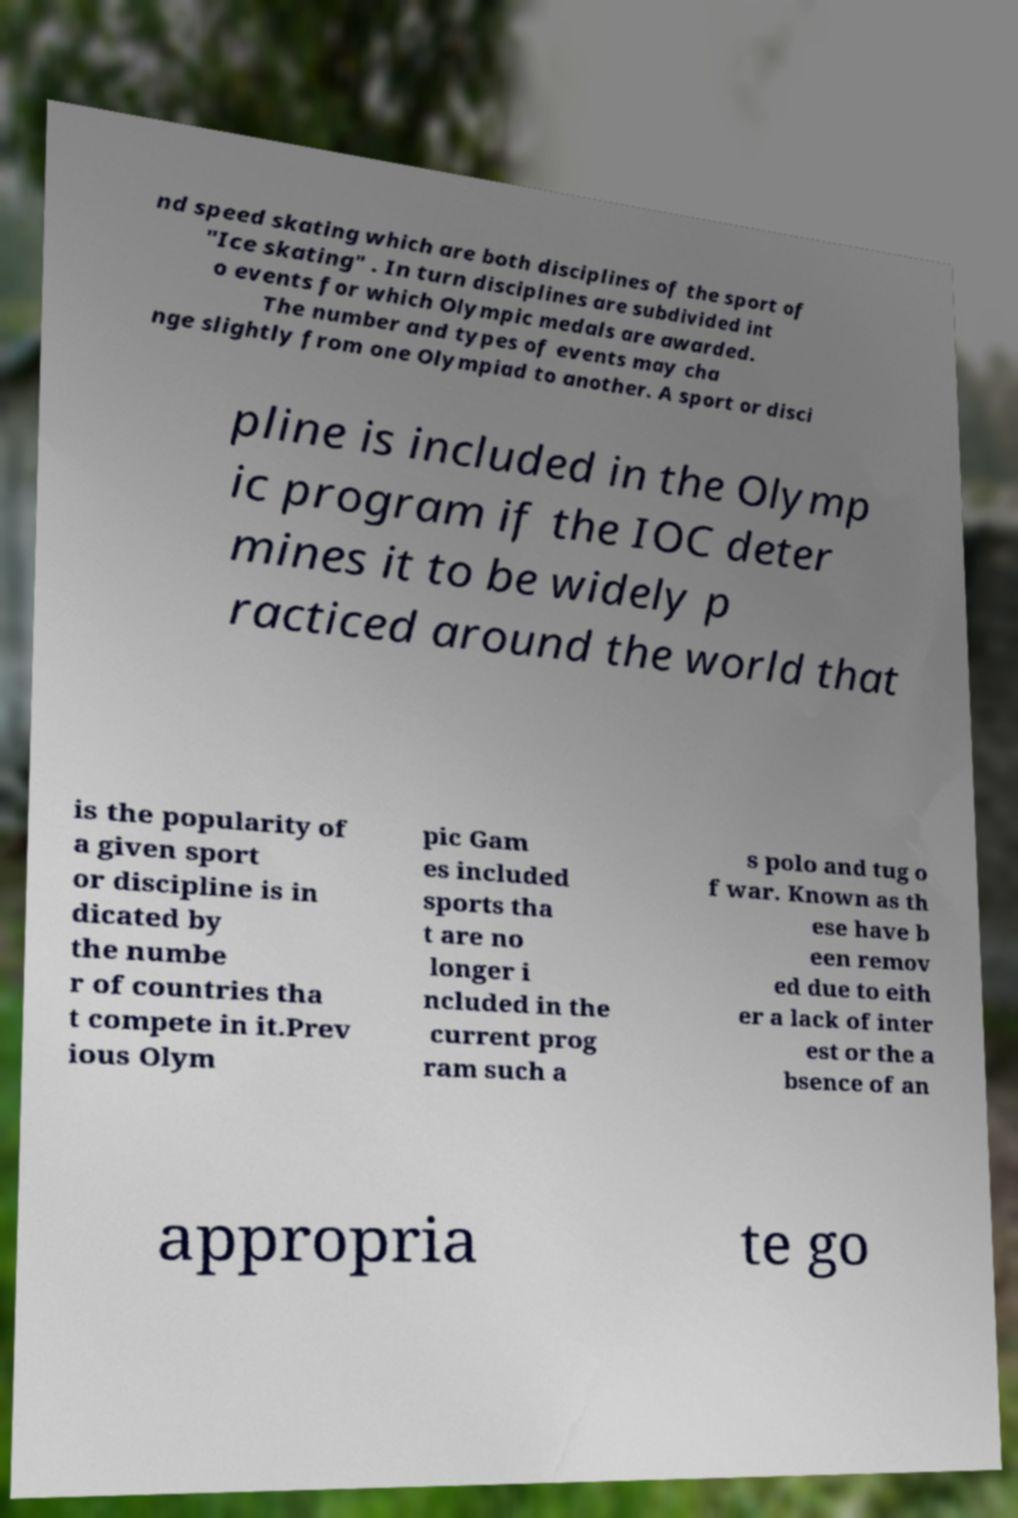Could you assist in decoding the text presented in this image and type it out clearly? nd speed skating which are both disciplines of the sport of "Ice skating" . In turn disciplines are subdivided int o events for which Olympic medals are awarded. The number and types of events may cha nge slightly from one Olympiad to another. A sport or disci pline is included in the Olymp ic program if the IOC deter mines it to be widely p racticed around the world that is the popularity of a given sport or discipline is in dicated by the numbe r of countries tha t compete in it.Prev ious Olym pic Gam es included sports tha t are no longer i ncluded in the current prog ram such a s polo and tug o f war. Known as th ese have b een remov ed due to eith er a lack of inter est or the a bsence of an appropria te go 